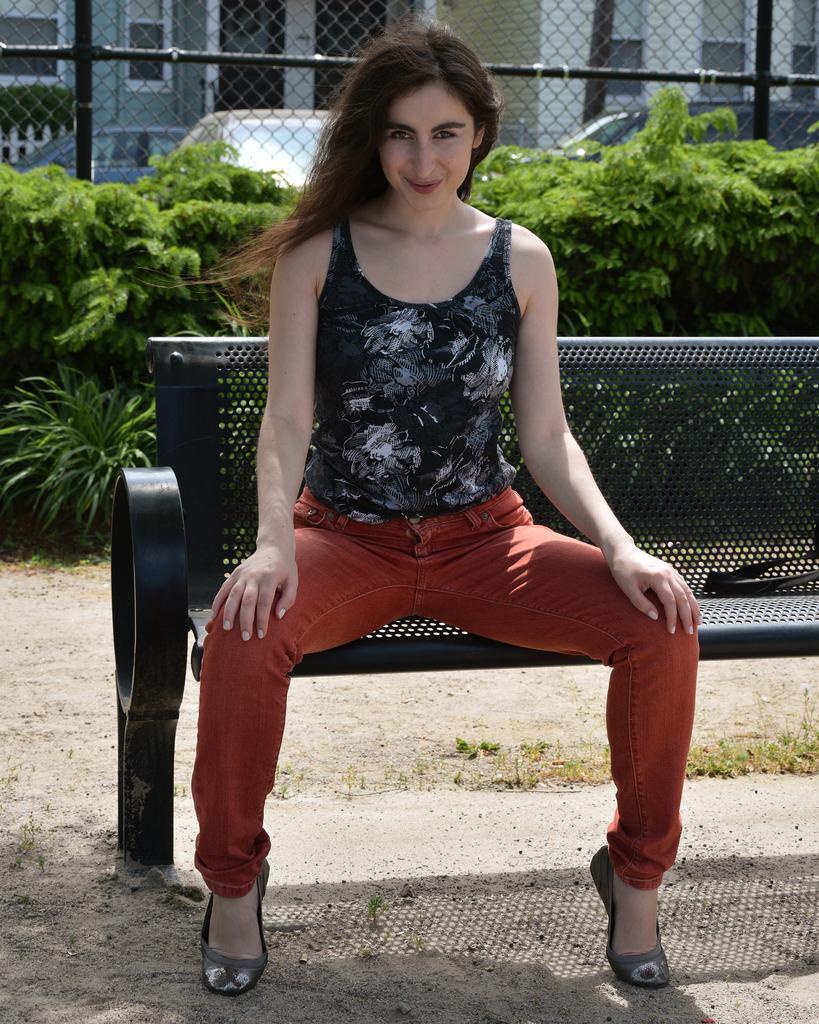In one or two sentences, can you explain what this image depicts? In the image we can see a woman sitting, wearing clothes, shoes and she is smiling. Here we can see the bench, grass and plants. We can even see there are vehicles, mesh and the building. 